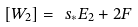<formula> <loc_0><loc_0><loc_500><loc_500>[ W _ { 2 } ] = \ s _ { * } E _ { 2 } + 2 F</formula> 